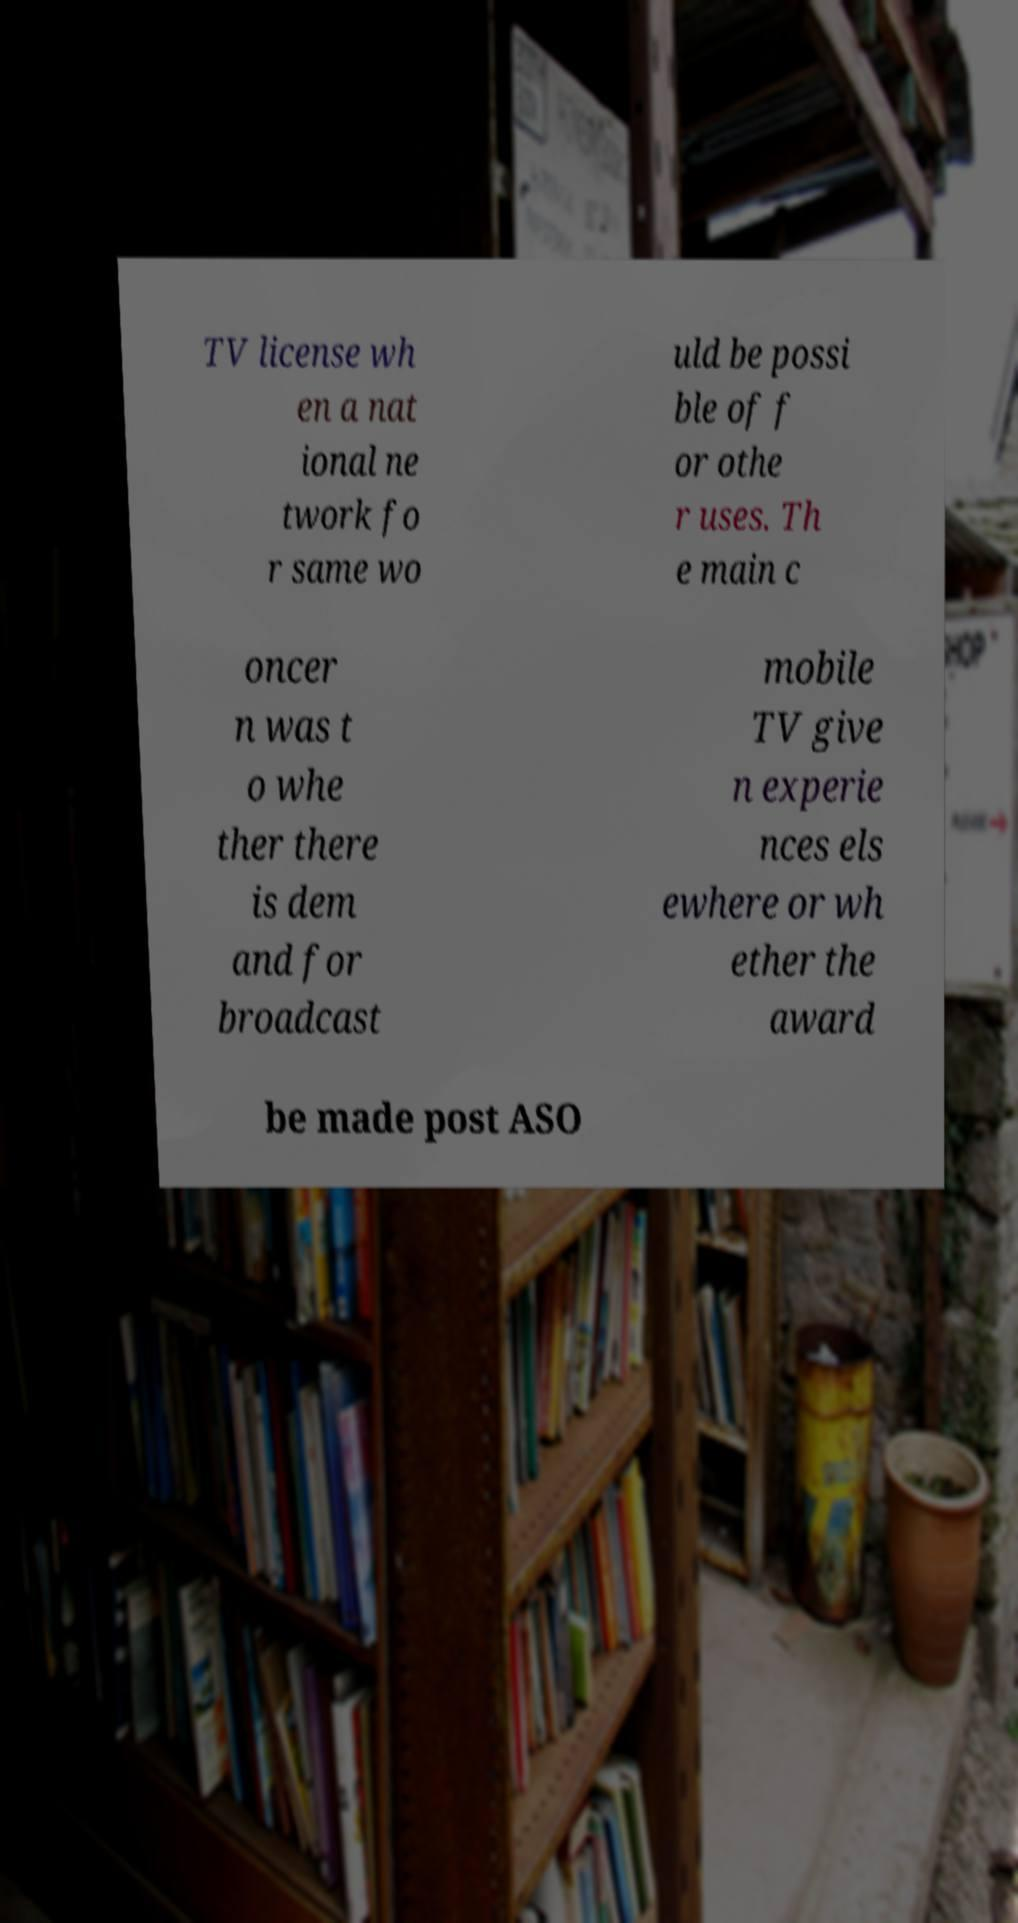Could you assist in decoding the text presented in this image and type it out clearly? TV license wh en a nat ional ne twork fo r same wo uld be possi ble of f or othe r uses. Th e main c oncer n was t o whe ther there is dem and for broadcast mobile TV give n experie nces els ewhere or wh ether the award be made post ASO 